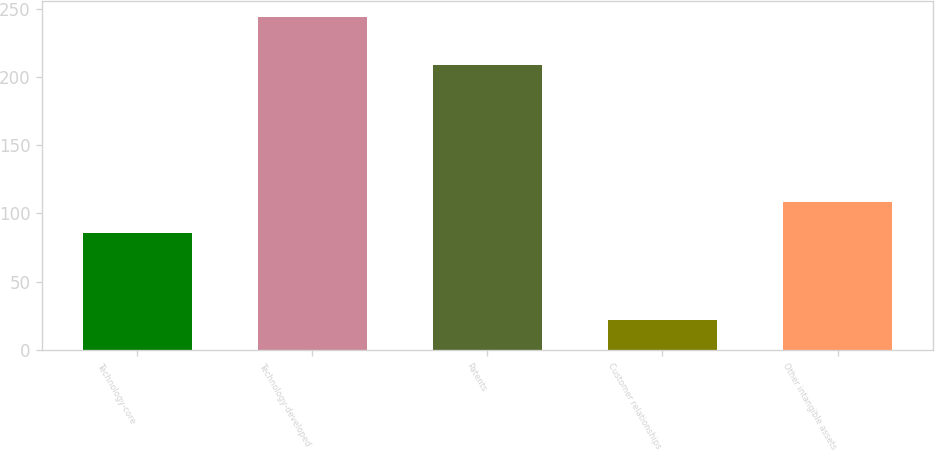Convert chart to OTSL. <chart><loc_0><loc_0><loc_500><loc_500><bar_chart><fcel>Technology-core<fcel>Technology-developed<fcel>Patents<fcel>Customer relationships<fcel>Other intangible assets<nl><fcel>86<fcel>244<fcel>209<fcel>22<fcel>108.2<nl></chart> 